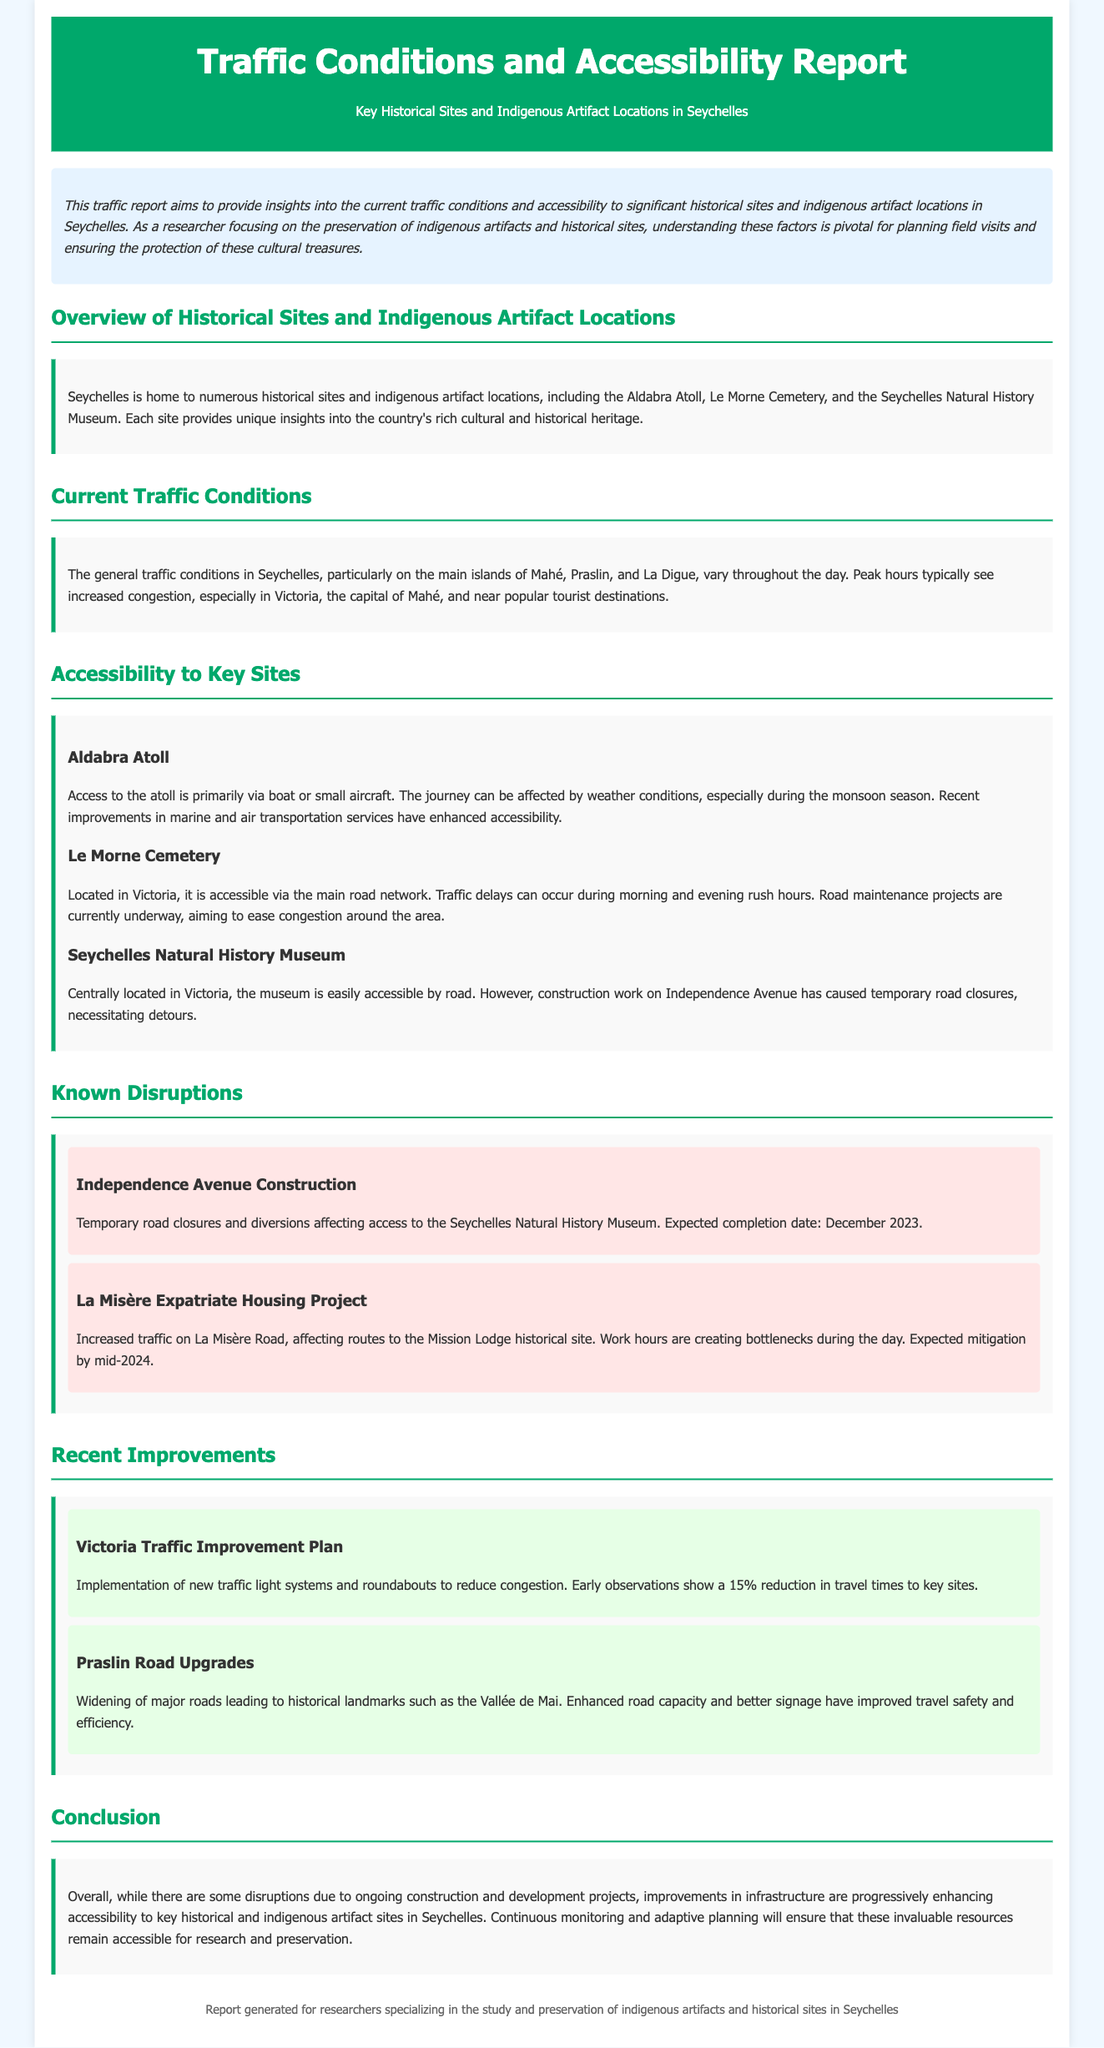What are the main islands mentioned? The main islands discussed in the traffic report are Mahé, Praslin, and La Digue.
Answer: Mahé, Praslin, La Digue What historical site is accessible via boat or small aircraft? The report states that Aldabra Atoll is primarily accessed by boat or small aircraft.
Answer: Aldabra Atoll What is causing traffic delays around Le Morne Cemetery? Traffic delays occur during rush hours due to increased congestion, particularly during morning and evening.
Answer: Rush hours What is the expected completion date for the Independence Avenue construction? The document specifies that the expected completion date for the Independence Avenue construction is December 2023.
Answer: December 2023 What recent improvement is mentioned for traffic in Victoria? The report mentions the implementation of new traffic light systems and roundabouts in Victoria.
Answer: New traffic light systems and roundabouts What percentage reduction in travel times to key sites has been observed? Early observations indicate a 15% reduction in travel times due to traffic improvements.
Answer: 15% What ongoing project is expected to create bottlenecks during the day? The La Misère Expatriate Housing Project is expected to create bottlenecks during the day.
Answer: La Misère Expatriate Housing Project Where is the Seychelles Natural History Museum located? The museum is centrally located in Victoria, as stated in the report.
Answer: Victoria 